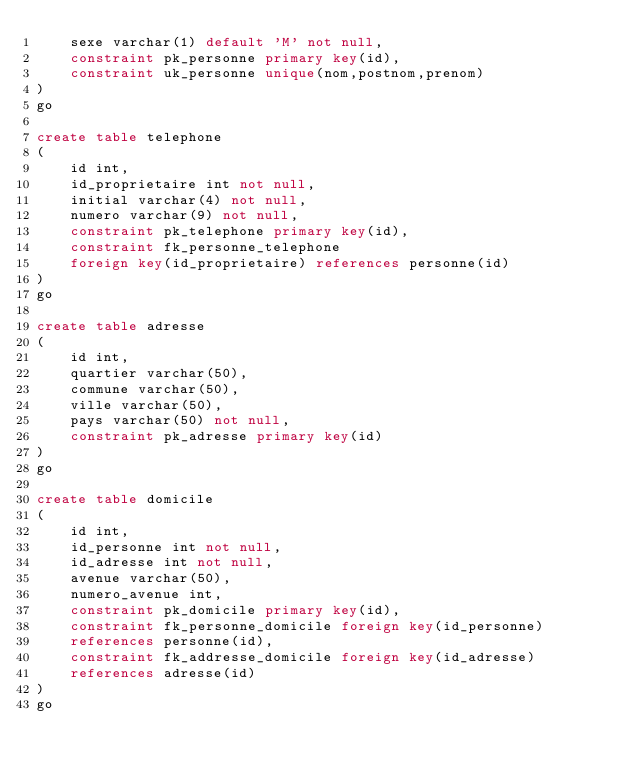Convert code to text. <code><loc_0><loc_0><loc_500><loc_500><_SQL_>	sexe varchar(1) default 'M' not null,
	constraint pk_personne primary key(id),
	constraint uk_personne unique(nom,postnom,prenom)
)
go

create table telephone 
(
	id int,
	id_proprietaire int not null,
	initial varchar(4) not null,
	numero varchar(9) not null,
	constraint pk_telephone primary key(id),
	constraint fk_personne_telephone 
	foreign key(id_proprietaire) references personne(id)
)
go

create table adresse
(
	id int,
	quartier varchar(50),
	commune varchar(50),
	ville varchar(50),
	pays varchar(50) not null,
	constraint pk_adresse primary key(id)
)
go

create table domicile
(
	id int,
	id_personne int not null,
	id_adresse int not null,
	avenue varchar(50),
	numero_avenue int,
	constraint pk_domicile primary key(id),
	constraint fk_personne_domicile foreign key(id_personne)
	references personne(id),
	constraint fk_addresse_domicile foreign key(id_adresse)
	references adresse(id)
)
go
</code> 